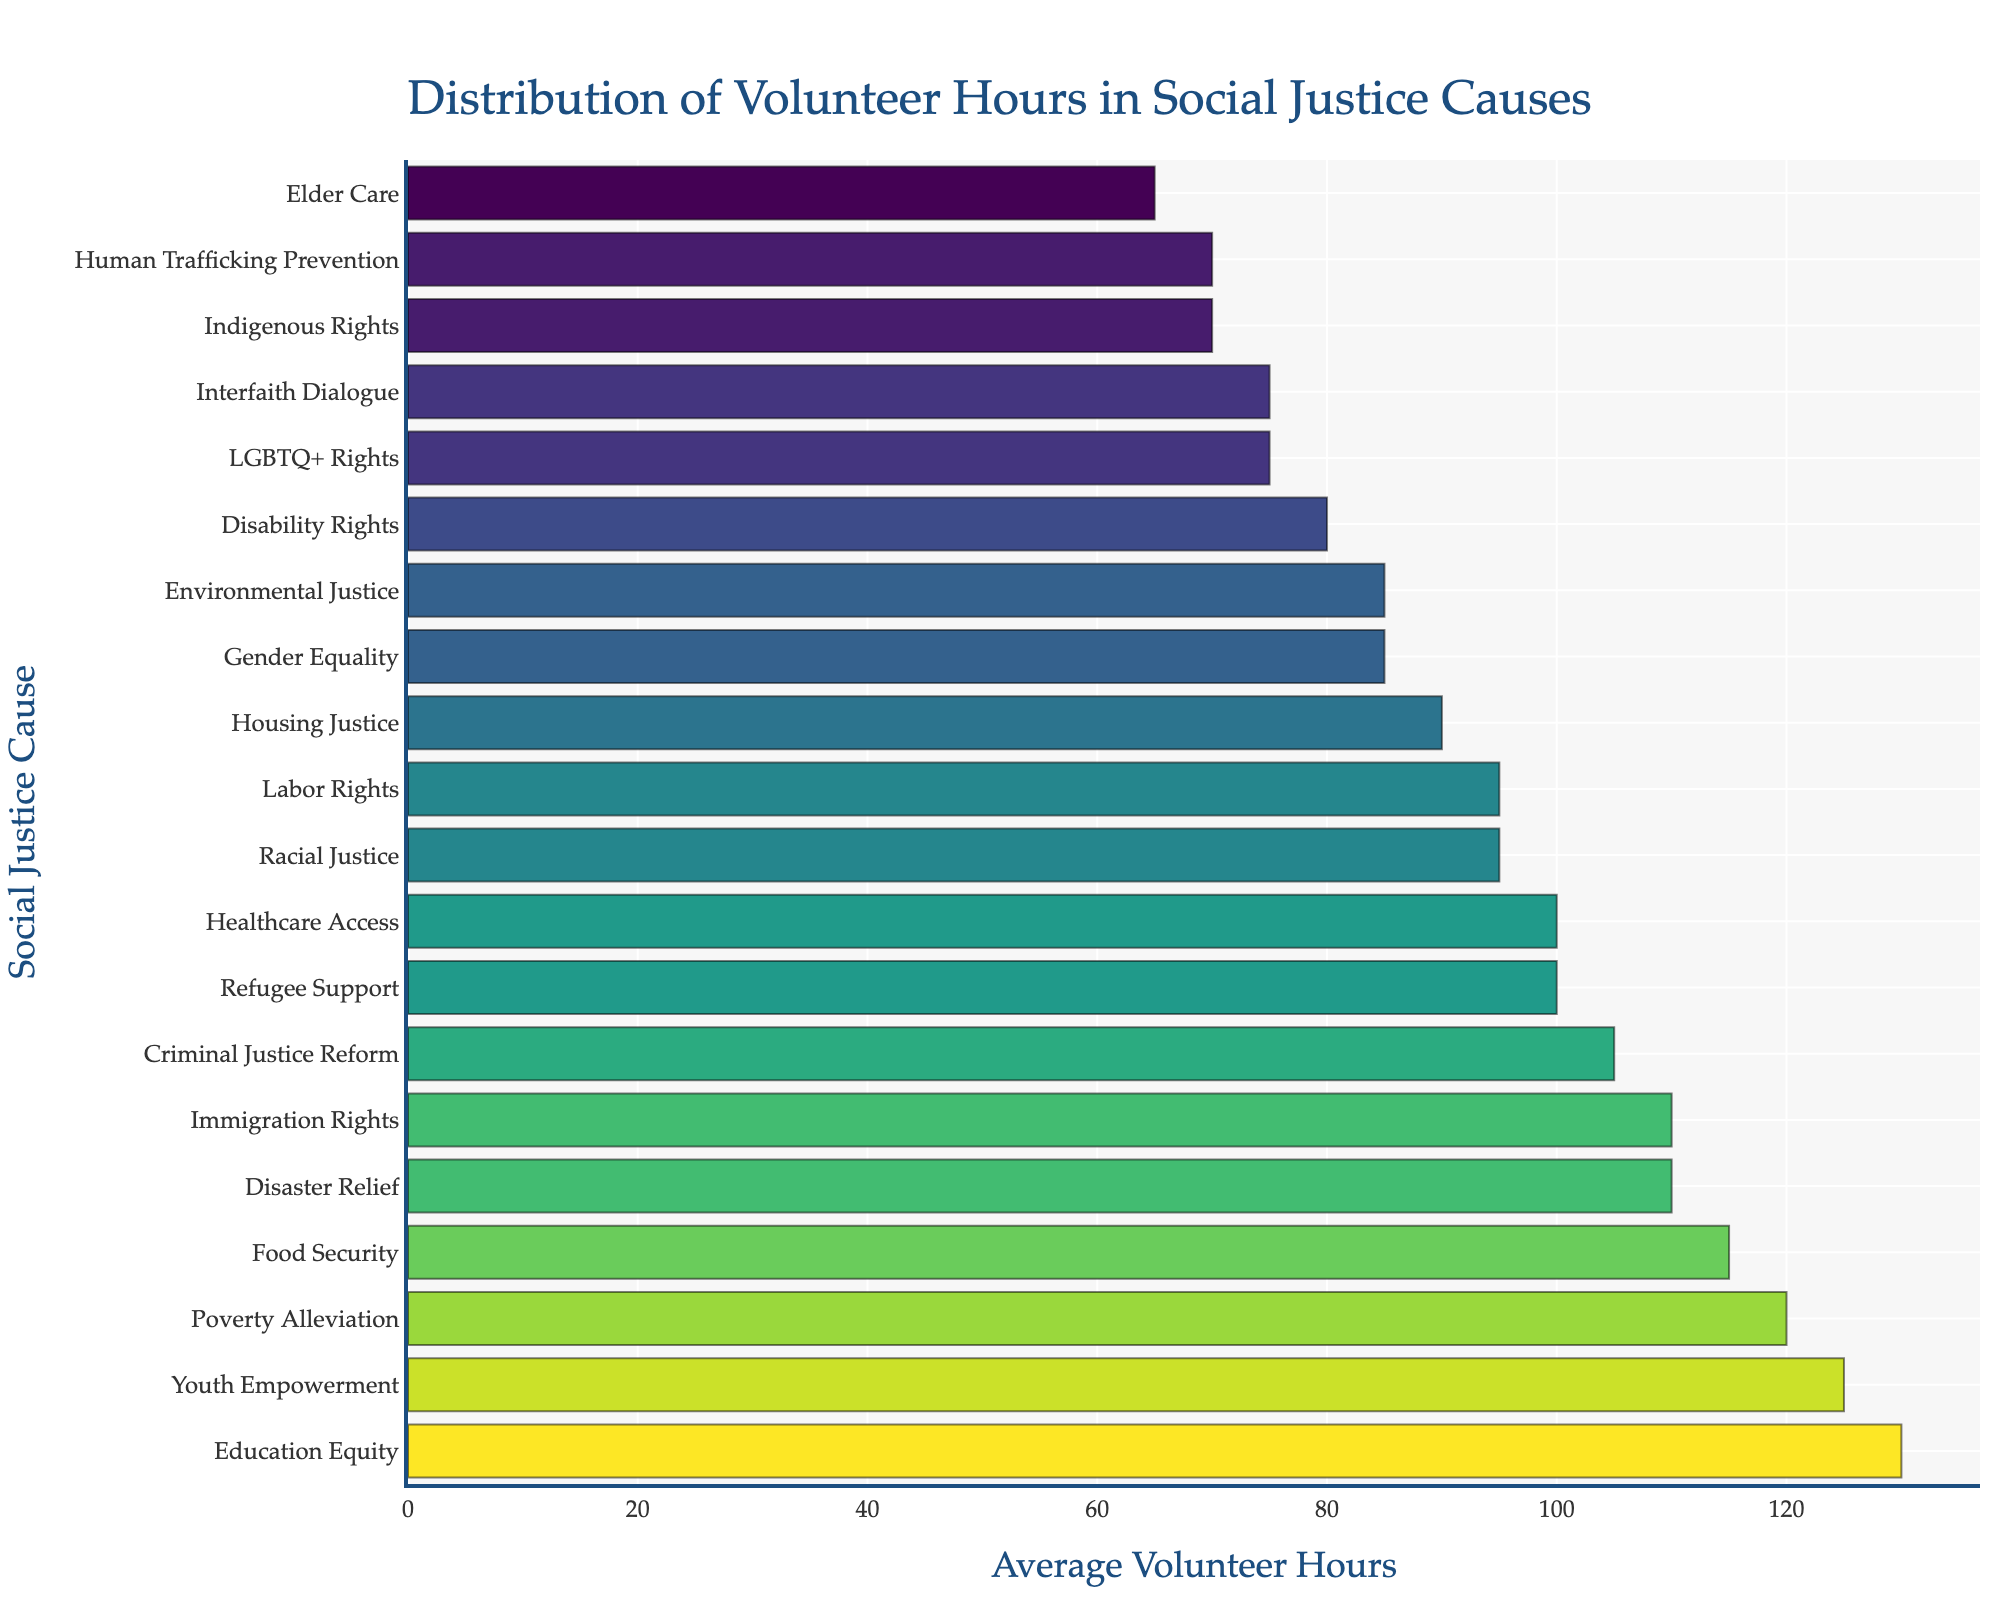Which cause has the highest average volunteer hours? By looking at the bar chart, identify the bar with the maximum length. This bar represents the cause with the highest average volunteer hours.
Answer: Education Equity Which cause has the lowest average volunteer hours? By looking at the bar chart, find the bar with the shortest length. This bar represents the cause with the lowest average volunteer hours.
Answer: Elder Care How much greater are the average volunteer hours for Poverty Alleviation compared to Elder Care? Identify the bars for Poverty Alleviation and Elder Care, and note their values. Subtract the value for Elder Care from the value for Poverty Alleviation (120 - 65).
Answer: 55 How do the average volunteer hours for Immigration Rights compare with those for Food Security? Look at the lengths of the bars representing Immigration Rights and Food Security. Both are of the same length.
Answer: Equal What is the sum of the average volunteer hours for Healthcare Access, Refugee Support, and Disaster Relief? Add the average volunteer hours for Healthcare Access (100), Refugee Support (100), and Disaster Relief (110) (100 + 100 + 110).
Answer: 310 Which causes have the same average volunteer hours? Observe the figure for bars with equal lengths. Identify these causes from the vertical labels.
Answer: Healthcare Access and Refugee Support; Labor Rights and Racial Justice; LGBTQ+ Rights and Interfaith Dialogue; Human Trafficking Prevention and Indigenous Rights Between Healthcare Access and Environmental Justice, which cause has lesser average volunteer hours? Compare the lengths of the bars for Healthcare Access and Environmental Justice. Identify the shorter bar and its corresponding cause.
Answer: Environmental Justice What is the median value of average volunteer hours across all causes? List the average volunteer hours in ascending order and find the middle value. If the number of values is even, calculate the average of the two middle values. (65, 70, 70, 75, 75, 80, 85, 85, 90, 95, 95, 100, 100, 105, 110, 110, 115, 120, 125, 130). The median is (95 + 100) / 2.
Answer: 97.5 